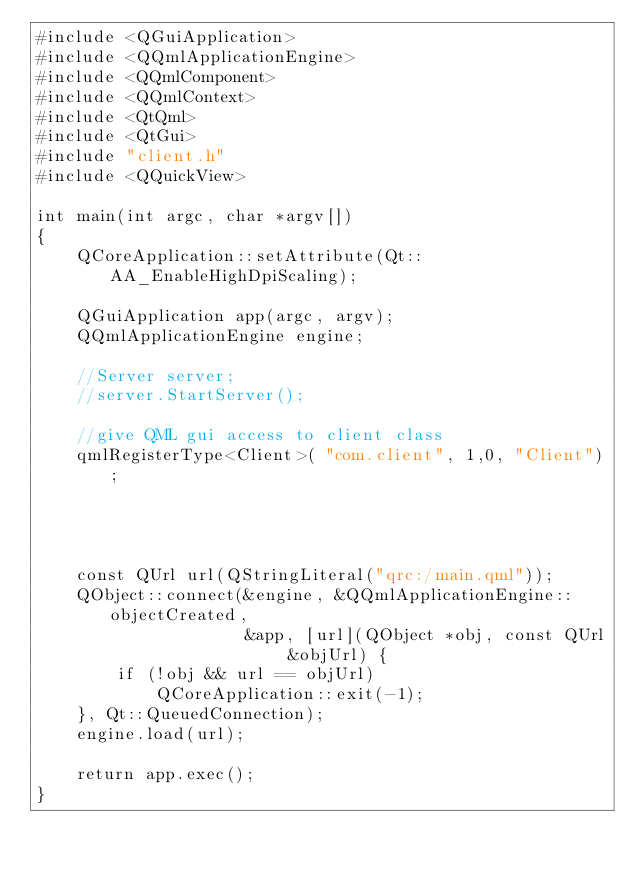Convert code to text. <code><loc_0><loc_0><loc_500><loc_500><_C++_>#include <QGuiApplication>
#include <QQmlApplicationEngine>
#include <QQmlComponent>
#include <QQmlContext>
#include <QtQml>
#include <QtGui>
#include "client.h"
#include <QQuickView>

int main(int argc, char *argv[])
{
    QCoreApplication::setAttribute(Qt::AA_EnableHighDpiScaling);

    QGuiApplication app(argc, argv);
    QQmlApplicationEngine engine;

    //Server server;
    //server.StartServer();

    //give QML gui access to client class
    qmlRegisterType<Client>( "com.client", 1,0, "Client");




    const QUrl url(QStringLiteral("qrc:/main.qml"));
    QObject::connect(&engine, &QQmlApplicationEngine::objectCreated,
                     &app, [url](QObject *obj, const QUrl &objUrl) {
        if (!obj && url == objUrl)
            QCoreApplication::exit(-1);
    }, Qt::QueuedConnection);
    engine.load(url);

    return app.exec();
}
</code> 